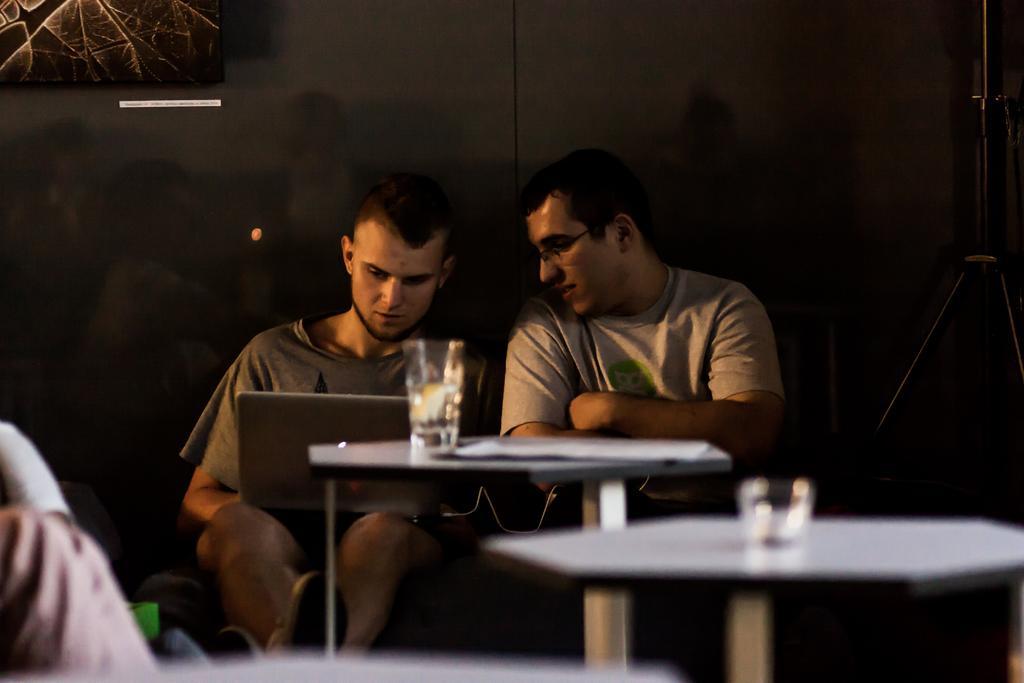Can you describe this image briefly? In this picture there are two man talking to each other , the second man is holding a laptop on his there are two tables in front of them and there are two glasses upon the table , in the background there is a wall and also a poster on the wall, to the right side there is a stand. 